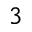<formula> <loc_0><loc_0><loc_500><loc_500>^ { 3 }</formula> 